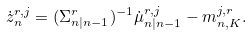<formula> <loc_0><loc_0><loc_500><loc_500>\dot { z } _ { n } ^ { r , j } = ( \Sigma _ { n | n - 1 } ^ { r } ) ^ { - 1 } \dot { \mu } _ { n | n - 1 } ^ { r , j } - m _ { n , K } ^ { j , r } .</formula> 